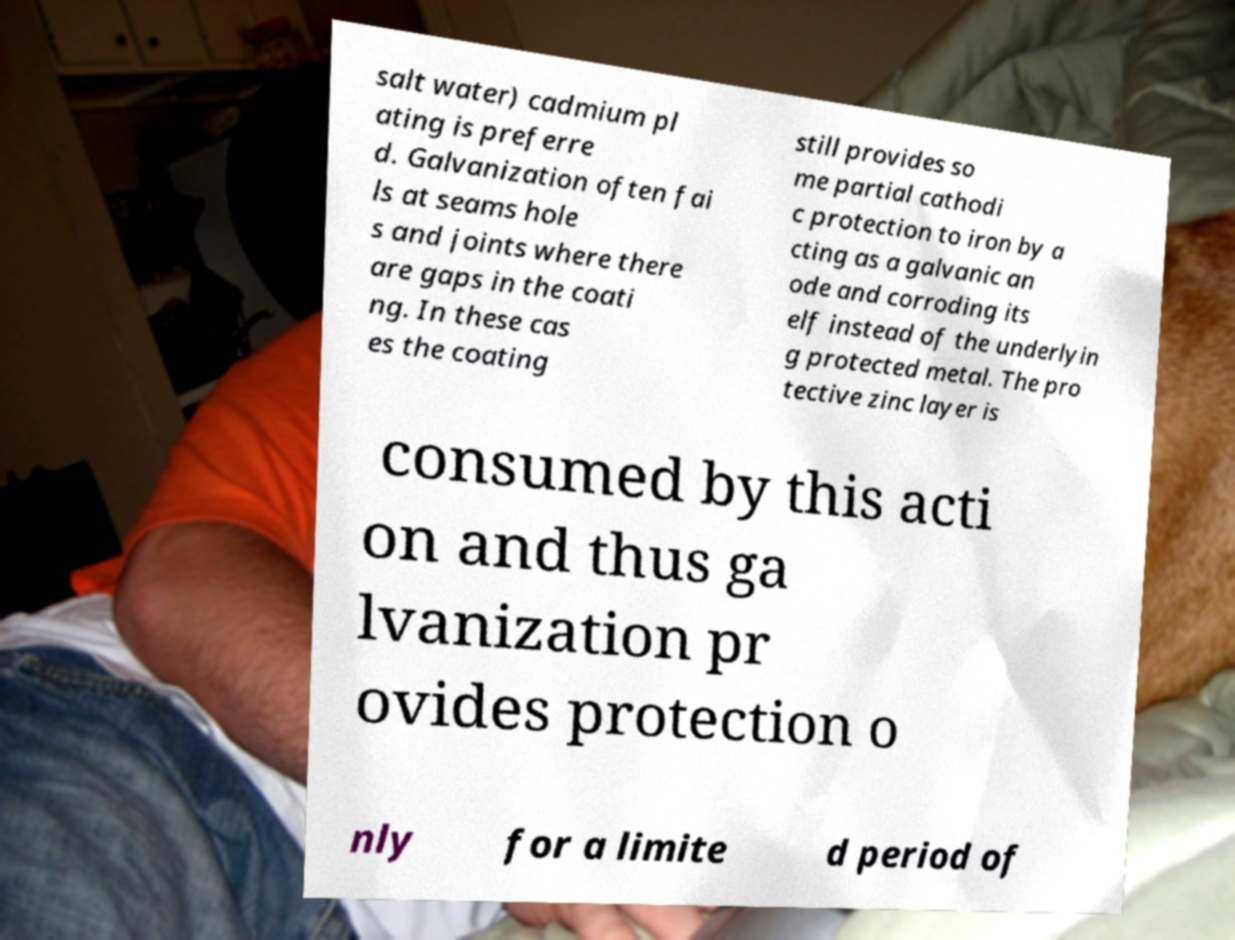What messages or text are displayed in this image? I need them in a readable, typed format. salt water) cadmium pl ating is preferre d. Galvanization often fai ls at seams hole s and joints where there are gaps in the coati ng. In these cas es the coating still provides so me partial cathodi c protection to iron by a cting as a galvanic an ode and corroding its elf instead of the underlyin g protected metal. The pro tective zinc layer is consumed by this acti on and thus ga lvanization pr ovides protection o nly for a limite d period of 